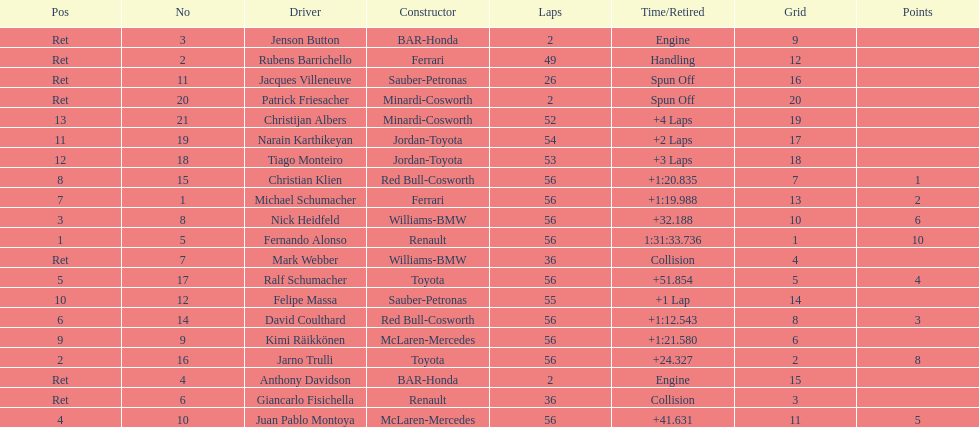How many drivers were retired before the race could end? 7. 